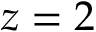<formula> <loc_0><loc_0><loc_500><loc_500>z = 2</formula> 